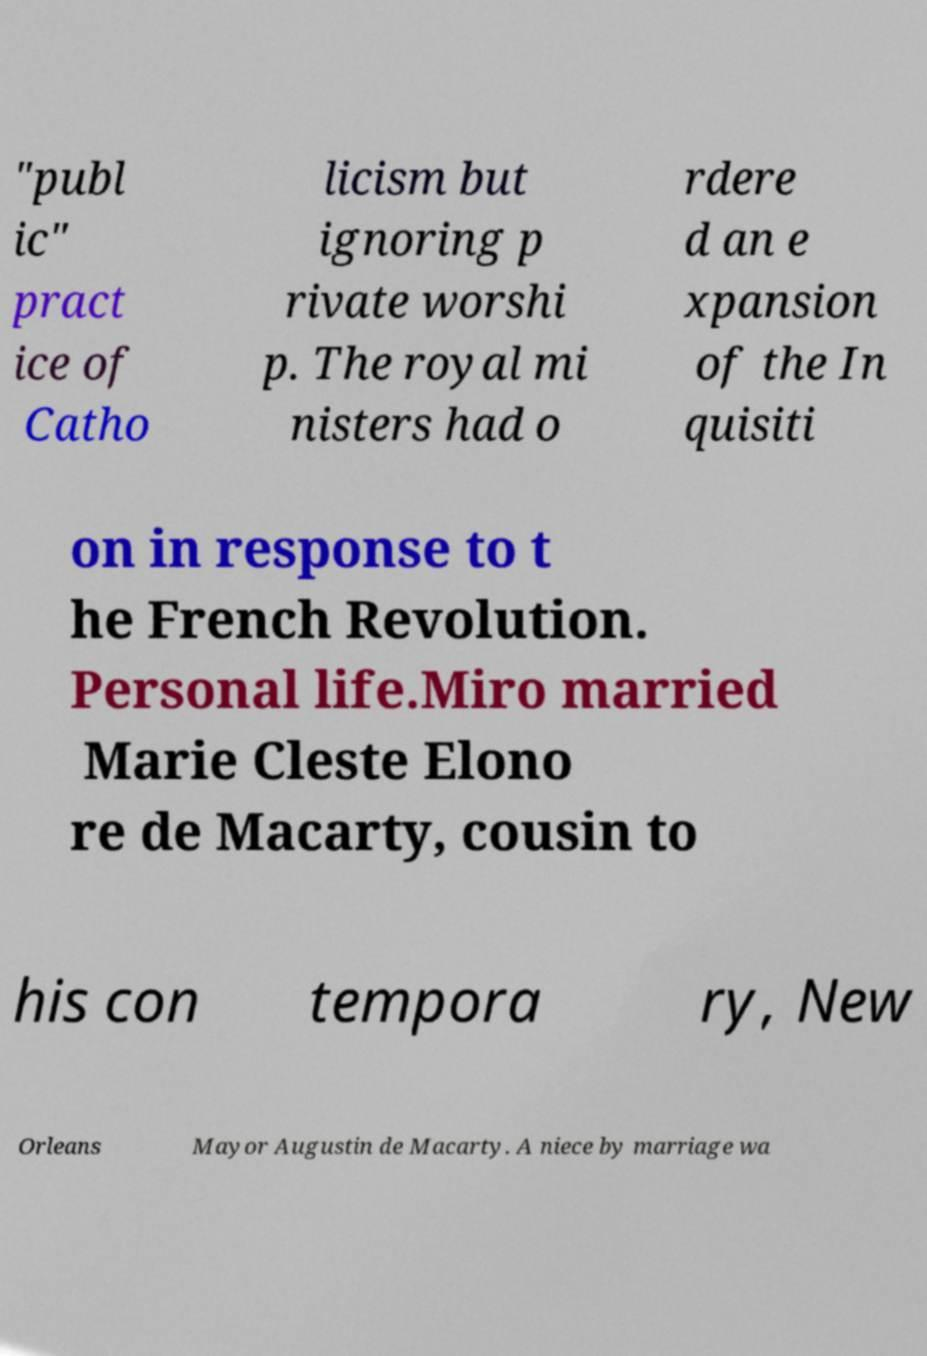Please identify and transcribe the text found in this image. "publ ic" pract ice of Catho licism but ignoring p rivate worshi p. The royal mi nisters had o rdere d an e xpansion of the In quisiti on in response to t he French Revolution. Personal life.Miro married Marie Cleste Elono re de Macarty, cousin to his con tempora ry, New Orleans Mayor Augustin de Macarty. A niece by marriage wa 